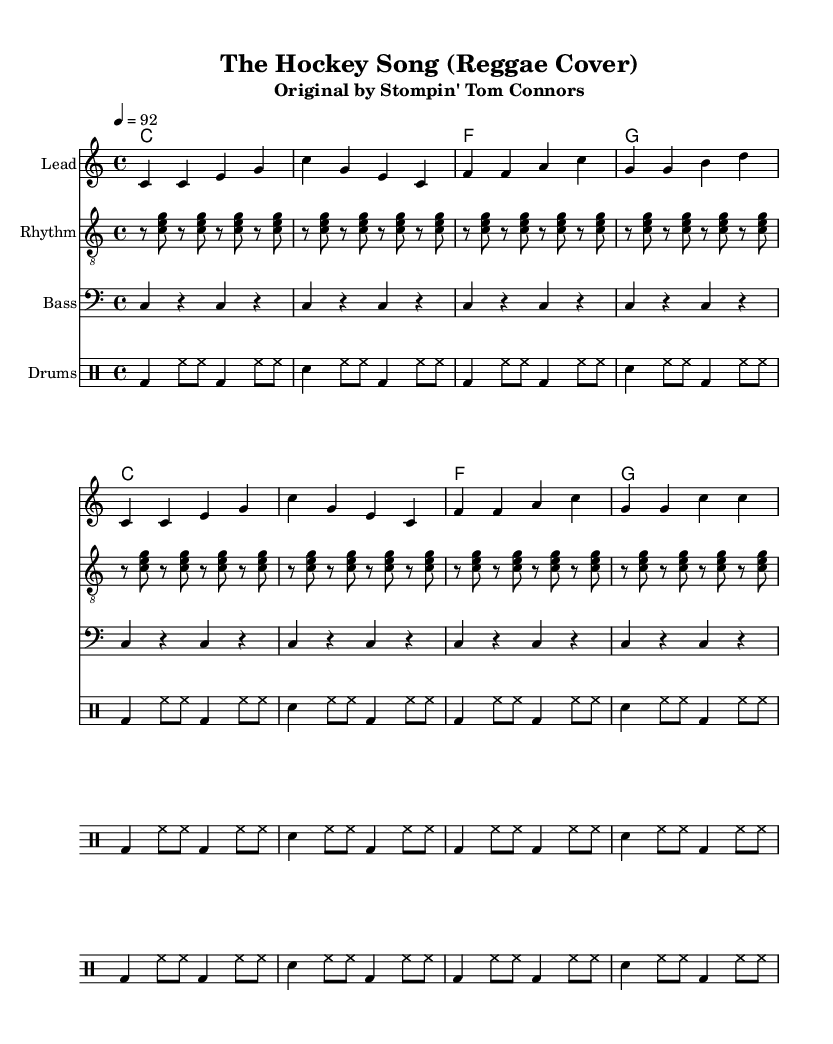What is the key signature of this music? The key signature is indicated at the beginning of the score, where it states "c \major," signifying that there are no sharps or flats in the piece.
Answer: C major What is the time signature of this music? The time signature is found in the first section of the music, displayed as "4/4," which means there are four beats in each measure and the quarter note receives one beat.
Answer: 4/4 What is the tempo marking of this music? The tempo is indicated at the start with "4 = 92," suggesting the piece should be played at 92 beats per minute, with each quarter note counting as one beat.
Answer: 92 How many measures are in the melody section? By counting the groups of notes, we can see that the melody has a total of 8 measures. Each measure consists of either a group of notes or rests.
Answer: 8 What instruments are included in this reggae arrangement? The score lists specific staves for each instrument, including "Lead," "Rhythm," "Bass," and "Drums." Each represents a different instrument used in the arrangement.
Answer: Lead, Rhythm, Bass, Drums What rhythmic pattern is primarily used in the rhythm guitar part? The rhythm guitar part primarily uses a repeating pattern of eighth notes for each chord played, as indicated by the repetitive structures written in the line for the rhythm guitar.
Answer: Eighth notes What distinguishes the reggae style in this arrangement? The reggae style is characterized by the offbeat rhythm that is notable in the accompaniment and guitar strumming patterns throughout the music. This offbeat emphasis is a core element of reggae music.
Answer: Offbeat rhythm 